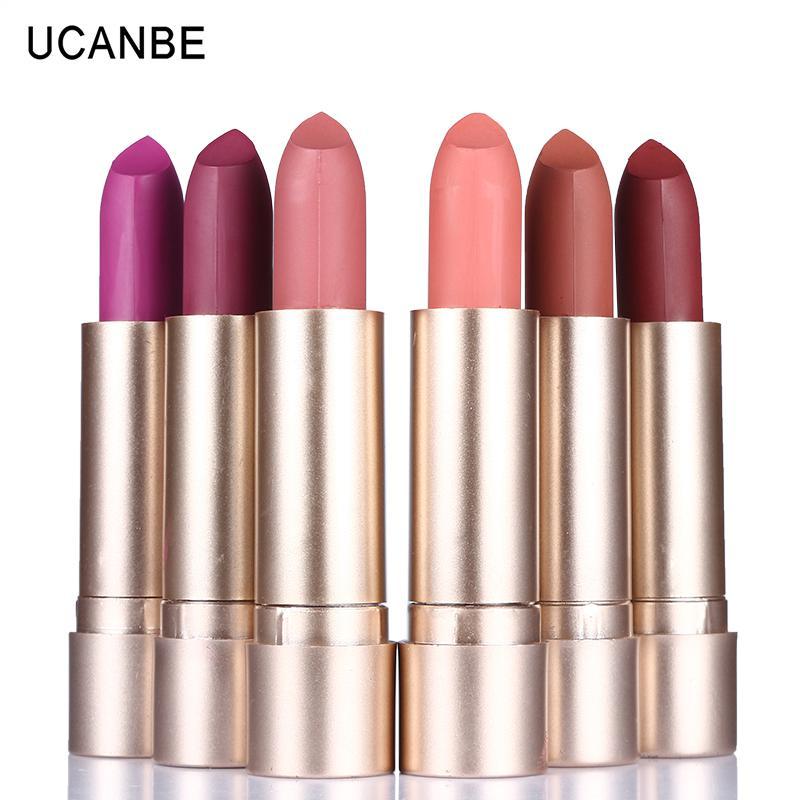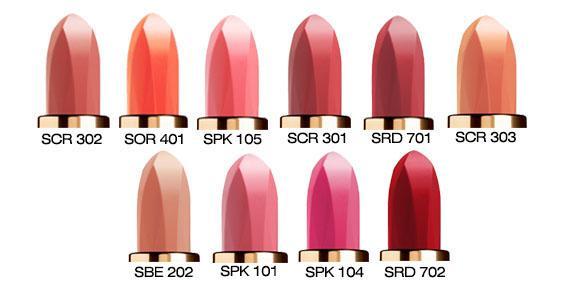The first image is the image on the left, the second image is the image on the right. Examine the images to the left and right. Is the description "The image to the left contains exactly 6 lipsticks." accurate? Answer yes or no. Yes. 